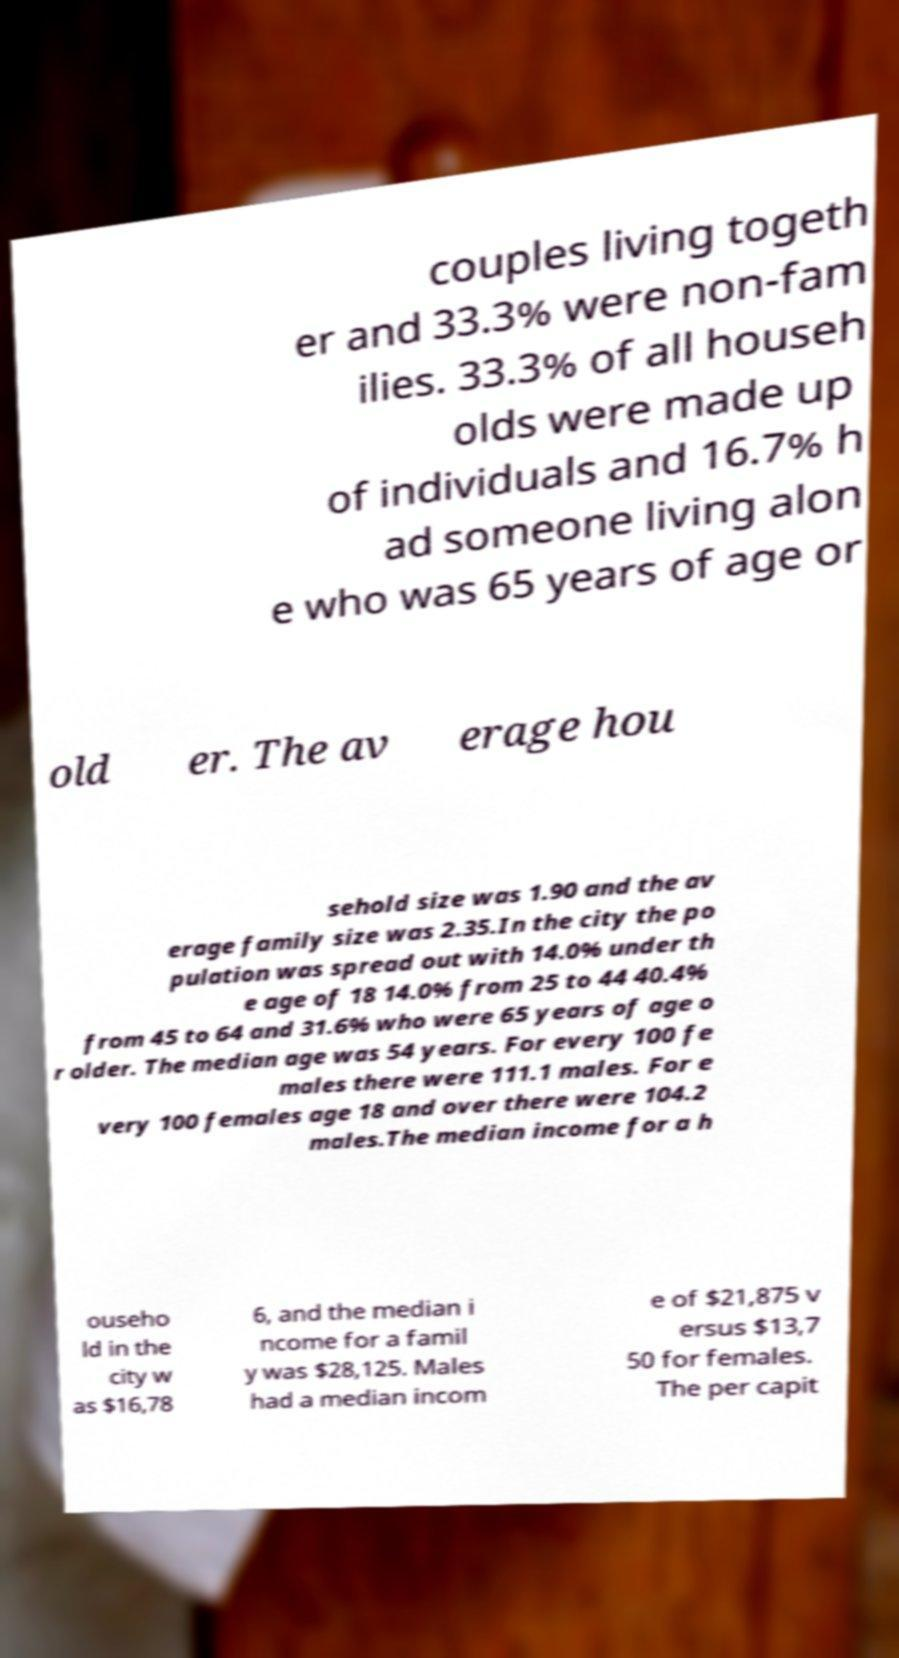I need the written content from this picture converted into text. Can you do that? couples living togeth er and 33.3% were non-fam ilies. 33.3% of all househ olds were made up of individuals and 16.7% h ad someone living alon e who was 65 years of age or old er. The av erage hou sehold size was 1.90 and the av erage family size was 2.35.In the city the po pulation was spread out with 14.0% under th e age of 18 14.0% from 25 to 44 40.4% from 45 to 64 and 31.6% who were 65 years of age o r older. The median age was 54 years. For every 100 fe males there were 111.1 males. For e very 100 females age 18 and over there were 104.2 males.The median income for a h ouseho ld in the city w as $16,78 6, and the median i ncome for a famil y was $28,125. Males had a median incom e of $21,875 v ersus $13,7 50 for females. The per capit 